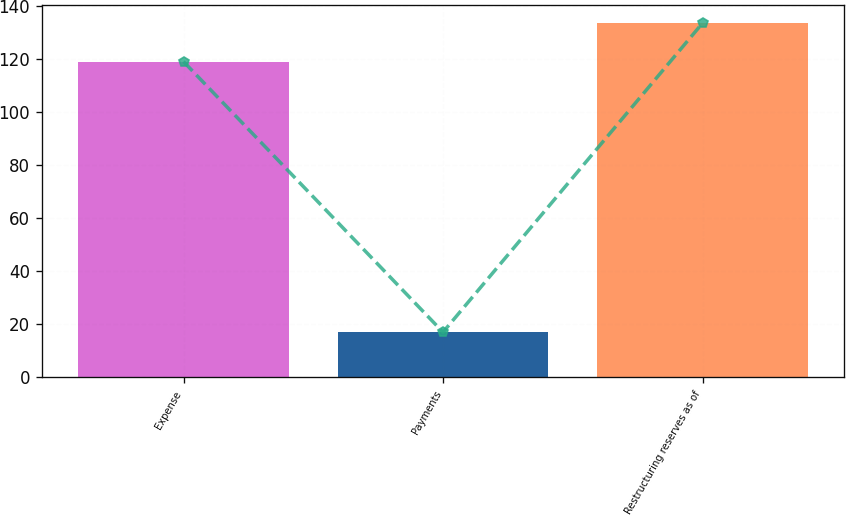<chart> <loc_0><loc_0><loc_500><loc_500><bar_chart><fcel>Expense<fcel>Payments<fcel>Restructuring reserves as of<nl><fcel>119<fcel>17<fcel>133.5<nl></chart> 